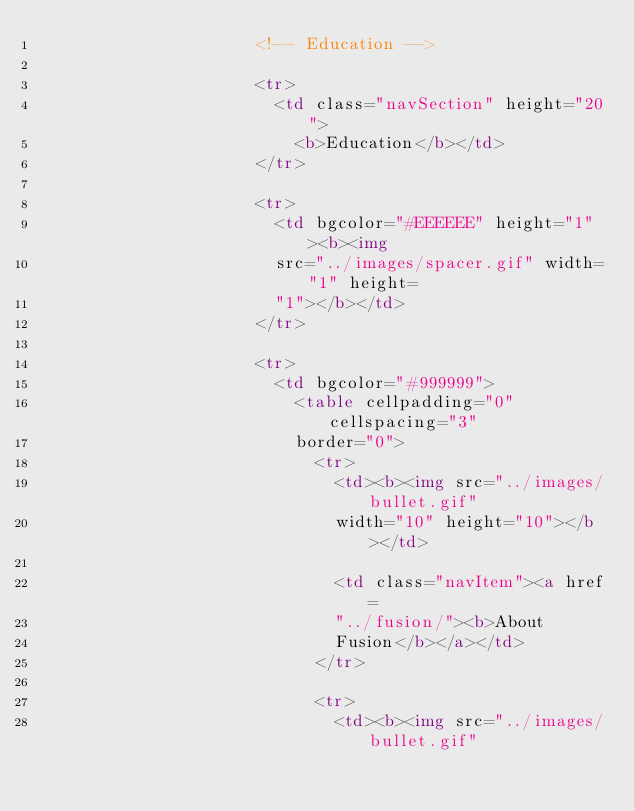<code> <loc_0><loc_0><loc_500><loc_500><_HTML_>                      <!-- Education -->

                      <tr>
                        <td class="navSection" height="20">
                          <b>Education</b></td>
                      </tr>

                      <tr>
                        <td bgcolor="#EEEEEE" height="1"><b><img
                        src="../images/spacer.gif" width="1" height=
                        "1"></b></td>
                      </tr>

                      <tr>
                        <td bgcolor="#999999">
                          <table cellpadding="0" cellspacing="3"
                          border="0">
                            <tr>
                              <td><b><img src="../images/bullet.gif"
                              width="10" height="10"></b></td>

                              <td class="navItem"><a href=
                              "../fusion/"><b>About
                              Fusion</b></a></td>
                            </tr>

                            <tr>
                              <td><b><img src="../images/bullet.gif"</code> 